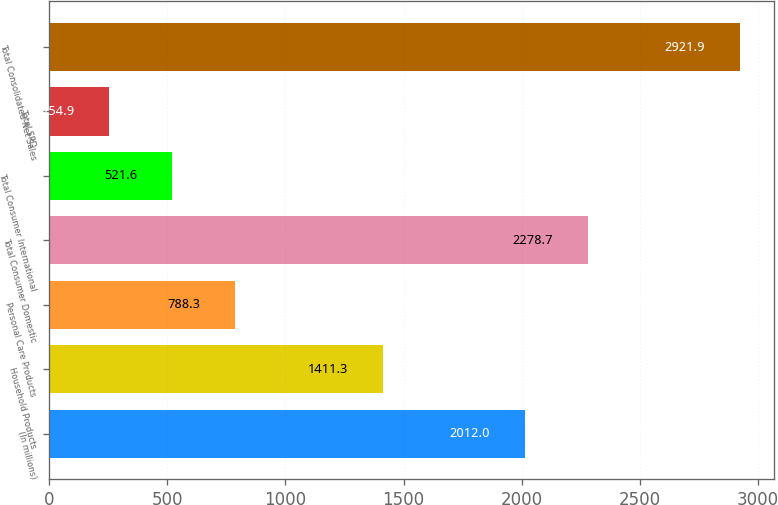<chart> <loc_0><loc_0><loc_500><loc_500><bar_chart><fcel>(In millions)<fcel>Household Products<fcel>Personal Care Products<fcel>Total Consumer Domestic<fcel>Total Consumer International<fcel>Total SPD<fcel>Total Consolidated Net Sales<nl><fcel>2012<fcel>1411.3<fcel>788.3<fcel>2278.7<fcel>521.6<fcel>254.9<fcel>2921.9<nl></chart> 